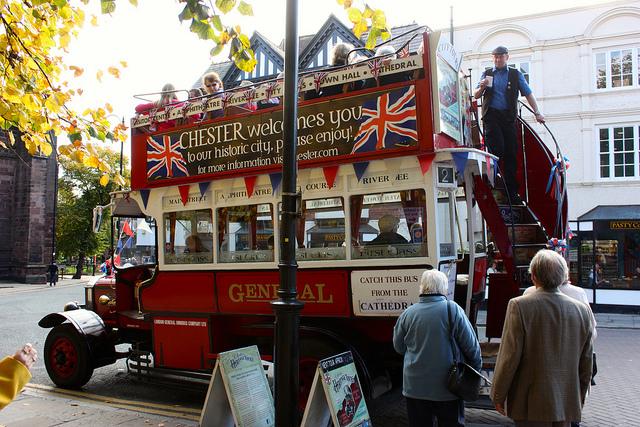How many people are standing on the bus stairs?
Give a very brief answer. 1. Is there an orange poster in this photo?
Short answer required. No. What is the name of the city this bus is touring?
Quick response, please. Chester. Who welcomes you?
Answer briefly. Chester. 